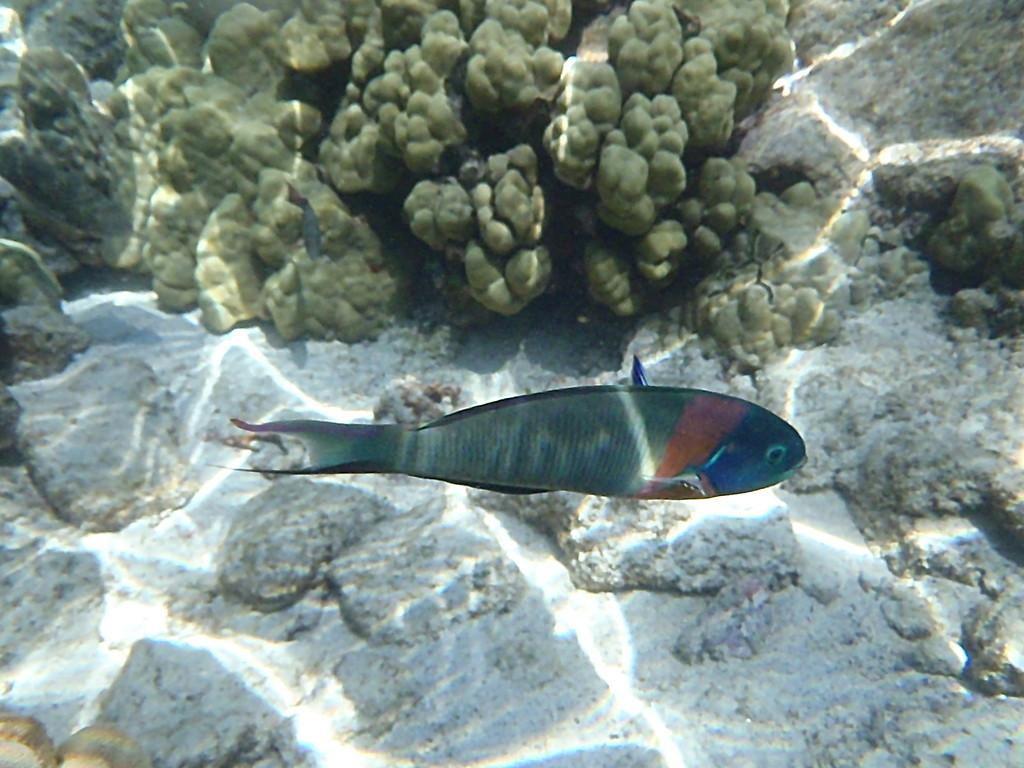What is the primary element visible in the image? There is water in the image. What can be found within the water? There is a fish in the water. What color is the crayon used to draw the fish in the image? There is no crayon or drawing present in the image; it is a photograph of a real fish in water. 